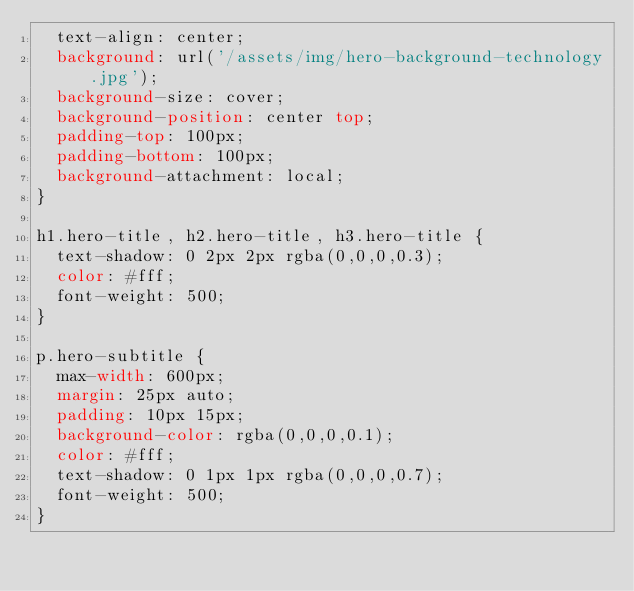<code> <loc_0><loc_0><loc_500><loc_500><_CSS_>  text-align: center;
  background: url('/assets/img/hero-background-technology.jpg');
  background-size: cover;
  background-position: center top;
  padding-top: 100px;
  padding-bottom: 100px;
  background-attachment: local;
}

h1.hero-title, h2.hero-title, h3.hero-title {
  text-shadow: 0 2px 2px rgba(0,0,0,0.3);
  color: #fff;
  font-weight: 500;
}

p.hero-subtitle {
  max-width: 600px;
  margin: 25px auto;
  padding: 10px 15px;
  background-color: rgba(0,0,0,0.1);
  color: #fff;
  text-shadow: 0 1px 1px rgba(0,0,0,0.7);
  font-weight: 500;
}

</code> 